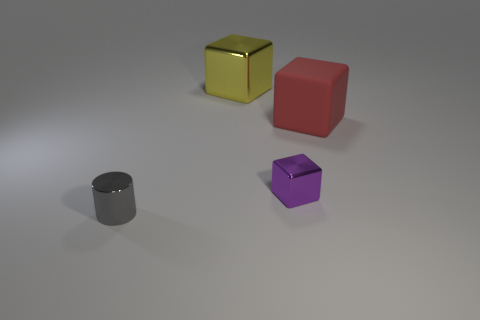What materials do the objects in the image look like they're made of? The objects in the image appear to be made of different types of materials. The shiny gold cube looks like it's metallic, possibly gold or a gold-tone metal. The matte red cube might be made of a plastic or painted wood. The tiny gray cylinder seems to have a metallic finish, suggesting it could be made of steel or aluminum. Lastly, the purple object, with its slightly reflective surface, suggests a material like colored glass or polished stone. 